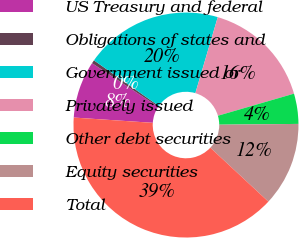Convert chart. <chart><loc_0><loc_0><loc_500><loc_500><pie_chart><fcel>US Treasury and federal<fcel>Obligations of states and<fcel>Government issued or<fcel>Privately issued<fcel>Other debt securities<fcel>Equity securities<fcel>Total<nl><fcel>8.21%<fcel>0.48%<fcel>19.81%<fcel>15.94%<fcel>4.34%<fcel>12.08%<fcel>39.14%<nl></chart> 